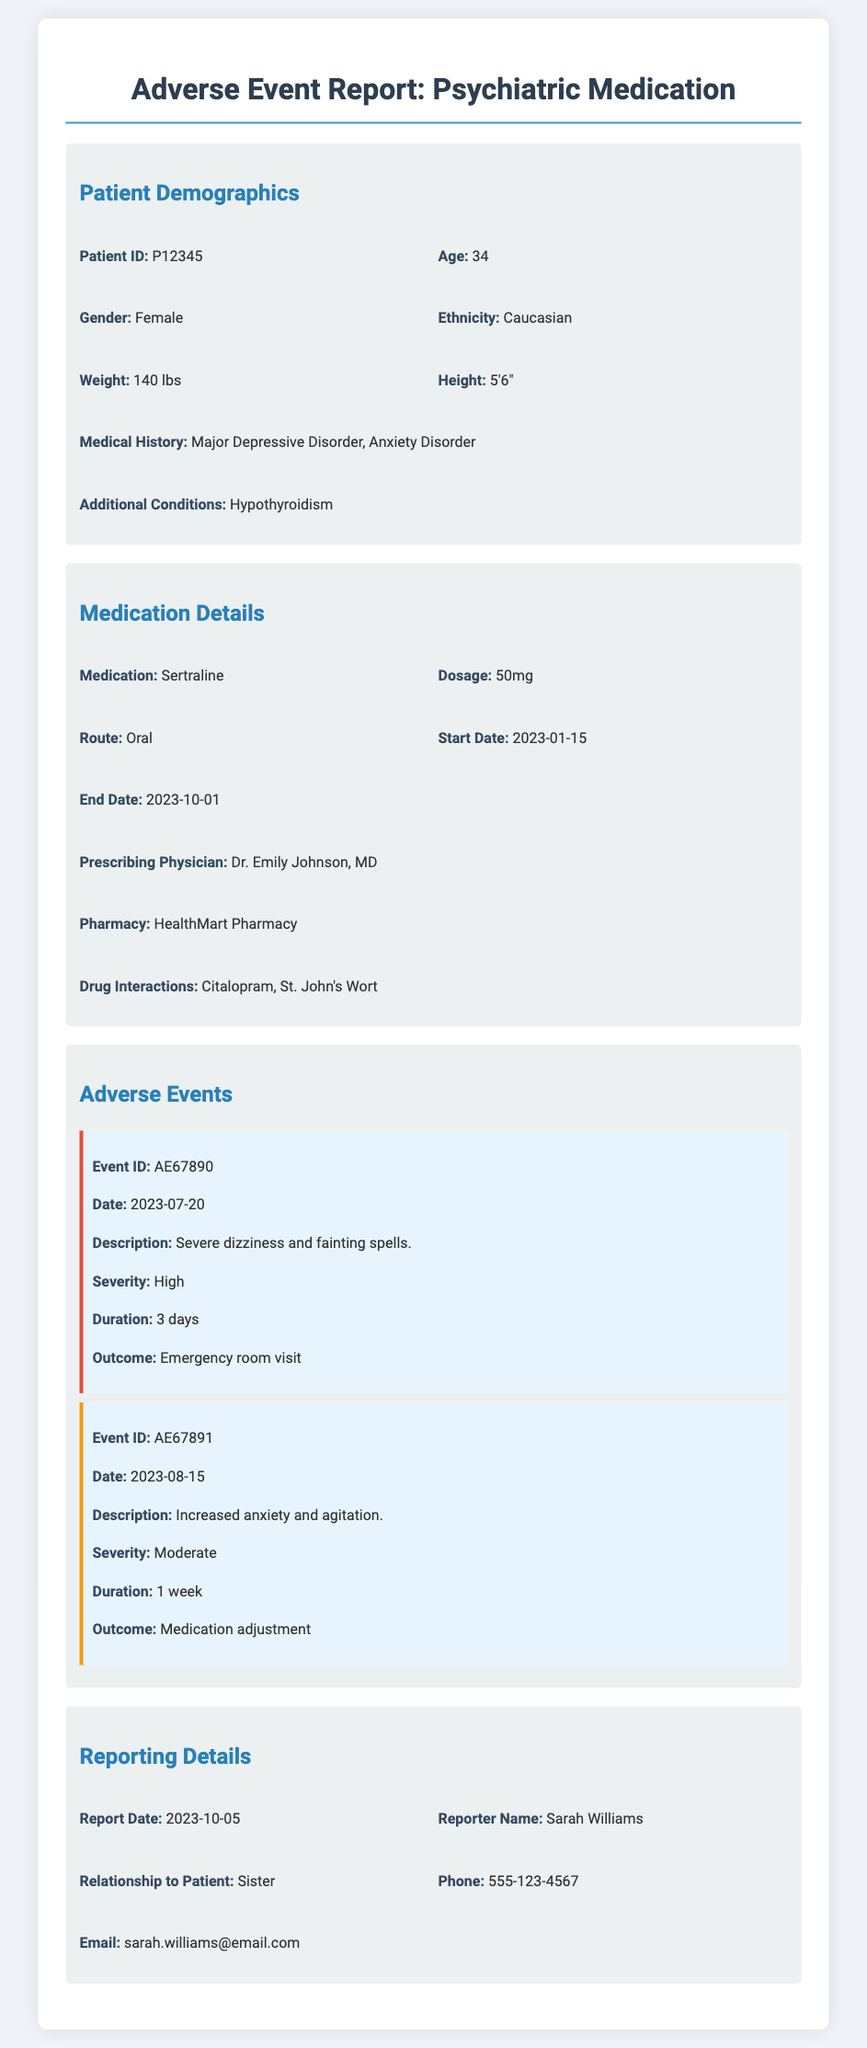what is the patient ID? The patient ID is a unique identifier for the patient in the report.
Answer: P12345 what is the age of the patient? The age is provided under patient demographics and reflects the patient's number of years lived.
Answer: 34 what medication was prescribed? The medication is the specific drug that the patient was taking during the reported adverse events.
Answer: Sertraline what is the dosage of the medication? The dosage refers to the amount of the medication taken by the patient.
Answer: 50mg what was the date of the first adverse event? The date provides the specific day on which the first recorded adverse event occurred.
Answer: 2023-07-20 how long did the high-severity event last? The duration indicates how long the high-severity event was experienced by the patient.
Answer: 3 days what was the outcome of the high-severity event? The outcome describes the result or action taken following the high-severity event.
Answer: Emergency room visit who reported the adverse events? The reporter's name indicates who provided the adverse event information in the report.
Answer: Sarah Williams what is the relationship of the reporter to the patient? The relationship details how the reporter is connected to the patient whose events are recorded.
Answer: Sister what additional condition does the patient have? The additional conditions are other health issues that the patient has besides the primary ones.
Answer: Hypothyroidism 